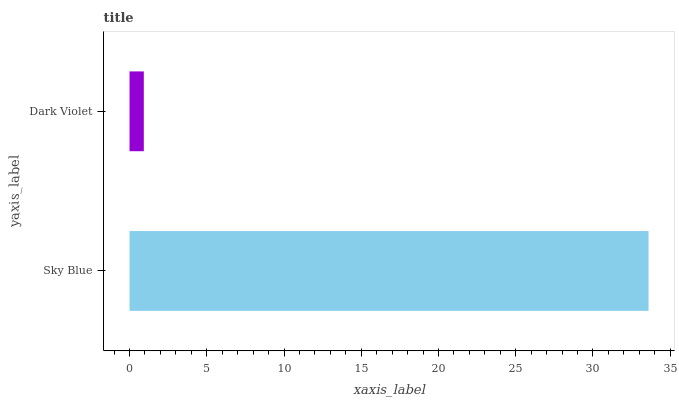Is Dark Violet the minimum?
Answer yes or no. Yes. Is Sky Blue the maximum?
Answer yes or no. Yes. Is Dark Violet the maximum?
Answer yes or no. No. Is Sky Blue greater than Dark Violet?
Answer yes or no. Yes. Is Dark Violet less than Sky Blue?
Answer yes or no. Yes. Is Dark Violet greater than Sky Blue?
Answer yes or no. No. Is Sky Blue less than Dark Violet?
Answer yes or no. No. Is Sky Blue the high median?
Answer yes or no. Yes. Is Dark Violet the low median?
Answer yes or no. Yes. Is Dark Violet the high median?
Answer yes or no. No. Is Sky Blue the low median?
Answer yes or no. No. 